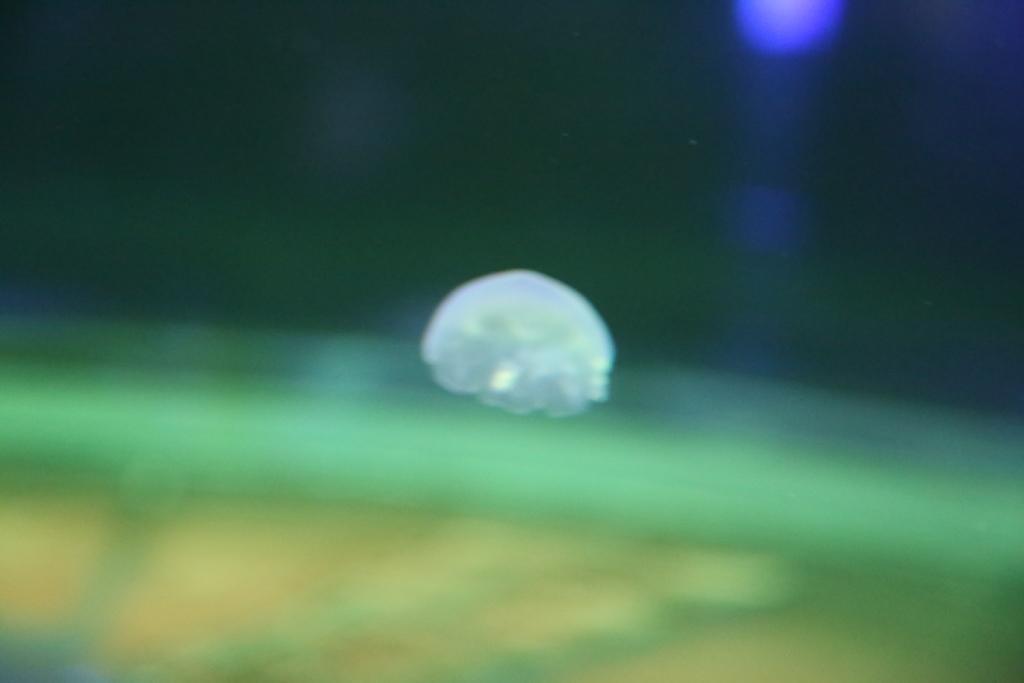Could you give a brief overview of what you see in this image? Here in this picture we can see something present in the air over there. 